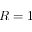Convert formula to latex. <formula><loc_0><loc_0><loc_500><loc_500>R = 1</formula> 